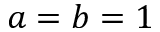Convert formula to latex. <formula><loc_0><loc_0><loc_500><loc_500>a = b = 1</formula> 